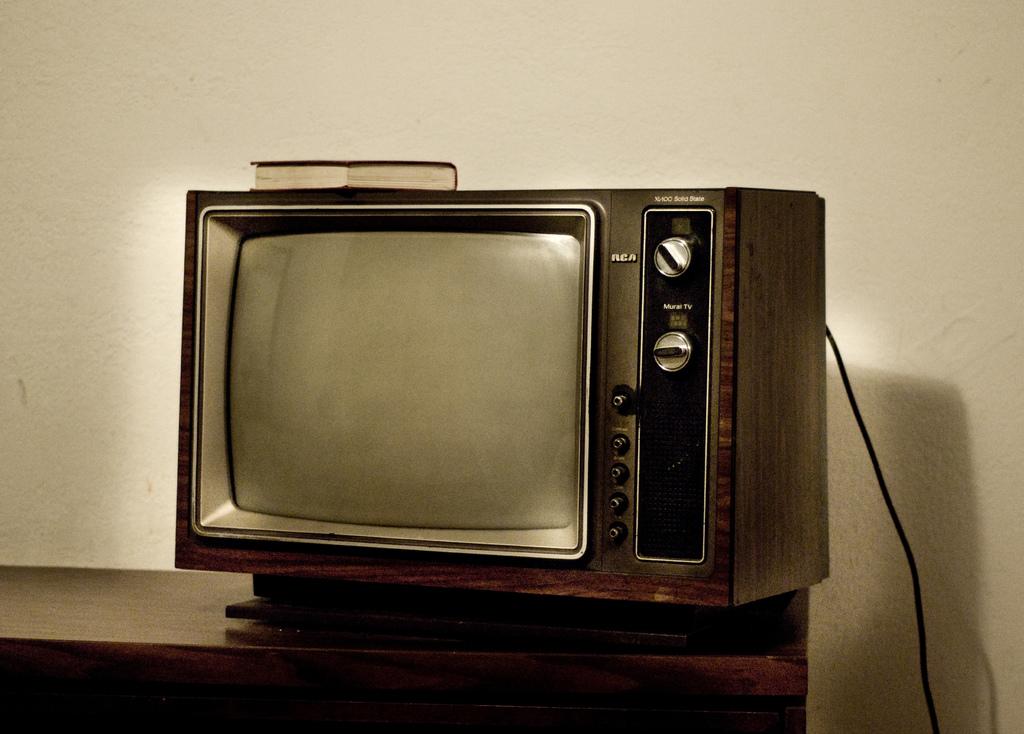What is the make of the tv?
Give a very brief answer. Rca. 